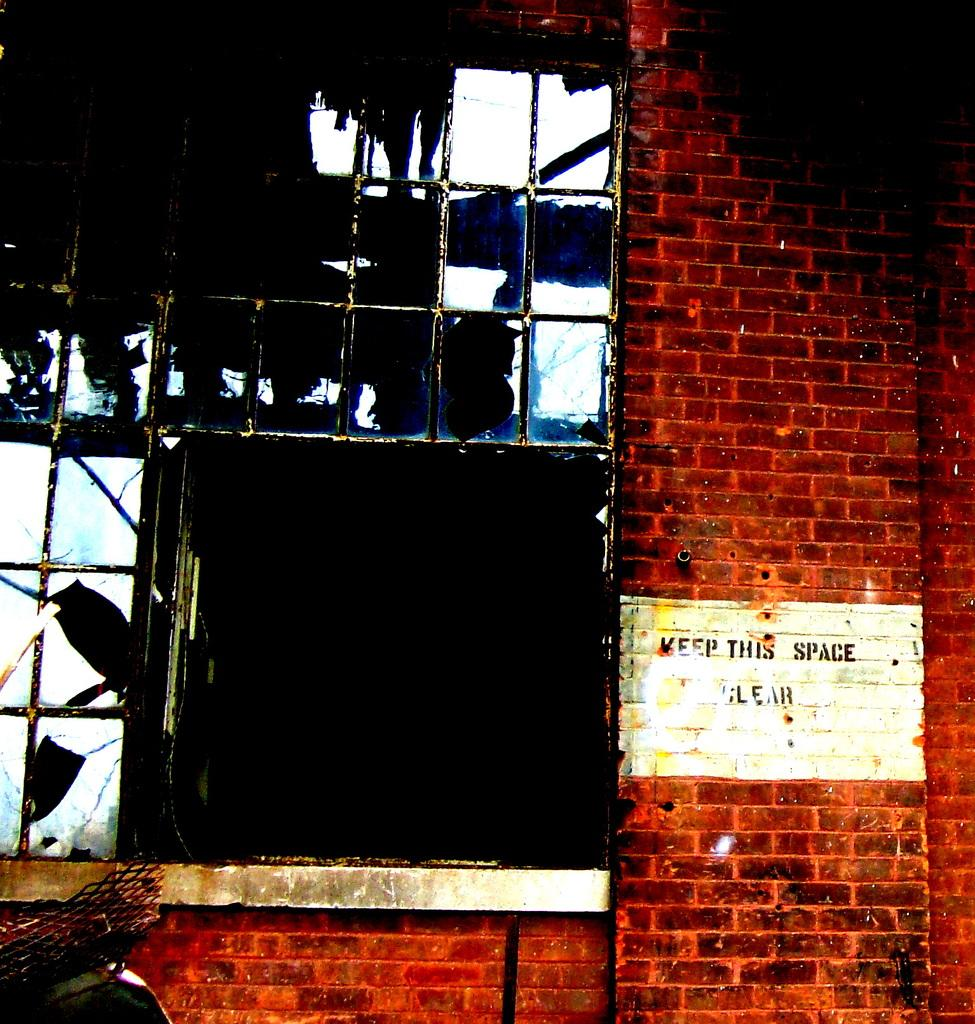What is written or displayed on the wall in the image? There is a wall with text in the image. Can you describe any other architectural features in the image? Yes, there is a window in the image. What type of material is present on the left side of the image? There is a mesh present on the left side of the image. How many balloons are tied to the mesh on the left side of the image? There are no balloons present in the image; it only features a mesh on the left side. What type of card is visible on the wall with text in the image? There is no card visible on the wall with text in the image. 